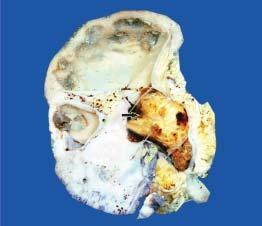does bdominal fat aspirate stained with congo red show dilated pelvicalyceal system with atrophied and thin peripheral cortex?
Answer the question using a single word or phrase. No 